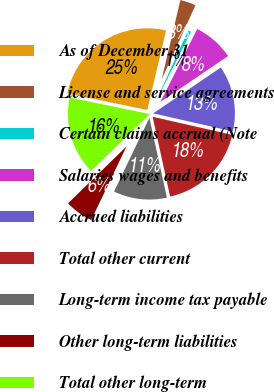Convert chart. <chart><loc_0><loc_0><loc_500><loc_500><pie_chart><fcel>As of December 31<fcel>License and service agreements<fcel>Certain claims accrual (Note<fcel>Salaries wages and benefits<fcel>Accrued liabilities<fcel>Total other current<fcel>Long-term income tax payable<fcel>Other long-term liabilities<fcel>Total other long-term<nl><fcel>25.45%<fcel>3.11%<fcel>0.63%<fcel>8.08%<fcel>13.04%<fcel>18.01%<fcel>10.56%<fcel>5.6%<fcel>15.52%<nl></chart> 